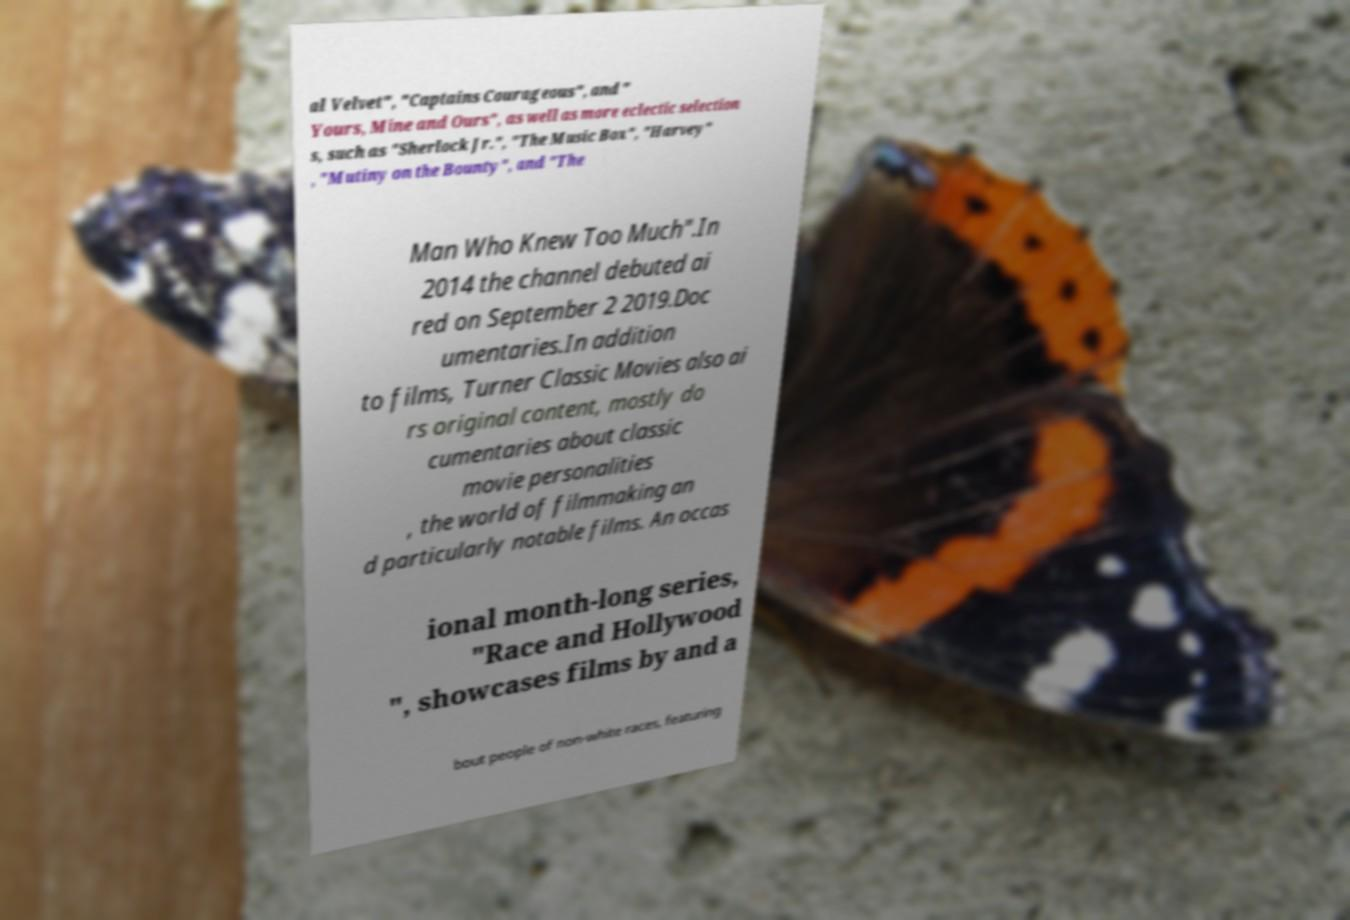Please read and relay the text visible in this image. What does it say? al Velvet", "Captains Courageous", and " Yours, Mine and Ours", as well as more eclectic selection s, such as "Sherlock Jr.", "The Music Box", "Harvey" , "Mutiny on the Bounty", and "The Man Who Knew Too Much".In 2014 the channel debuted ai red on September 2 2019.Doc umentaries.In addition to films, Turner Classic Movies also ai rs original content, mostly do cumentaries about classic movie personalities , the world of filmmaking an d particularly notable films. An occas ional month-long series, "Race and Hollywood ", showcases films by and a bout people of non-white races, featuring 